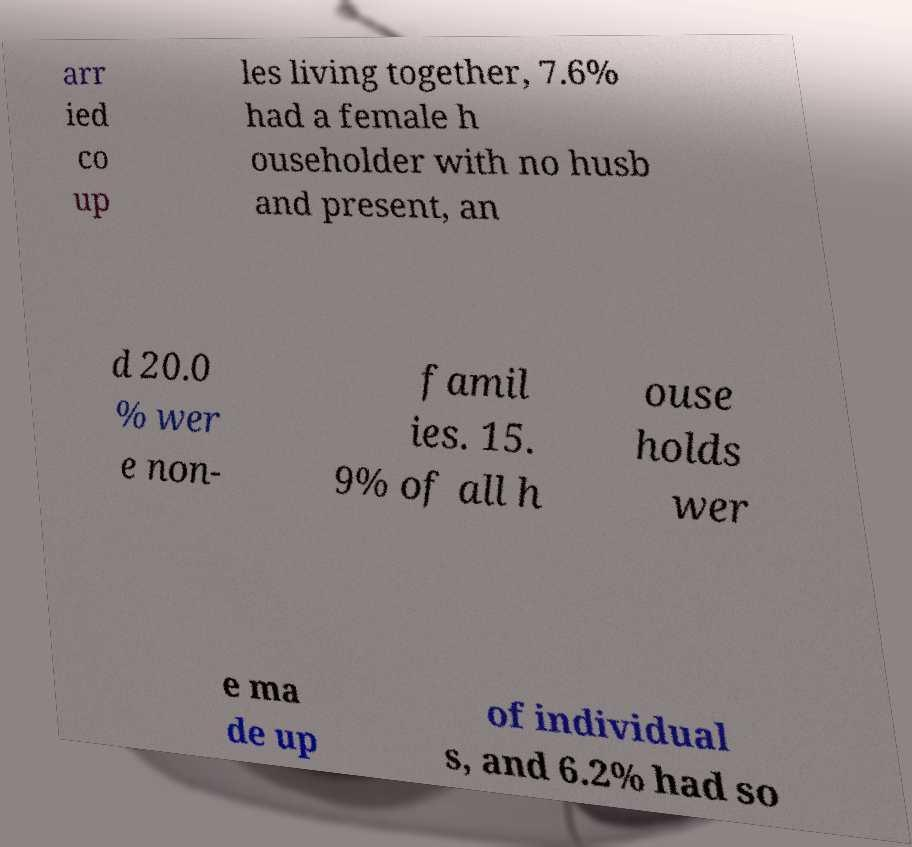Please read and relay the text visible in this image. What does it say? arr ied co up les living together, 7.6% had a female h ouseholder with no husb and present, an d 20.0 % wer e non- famil ies. 15. 9% of all h ouse holds wer e ma de up of individual s, and 6.2% had so 